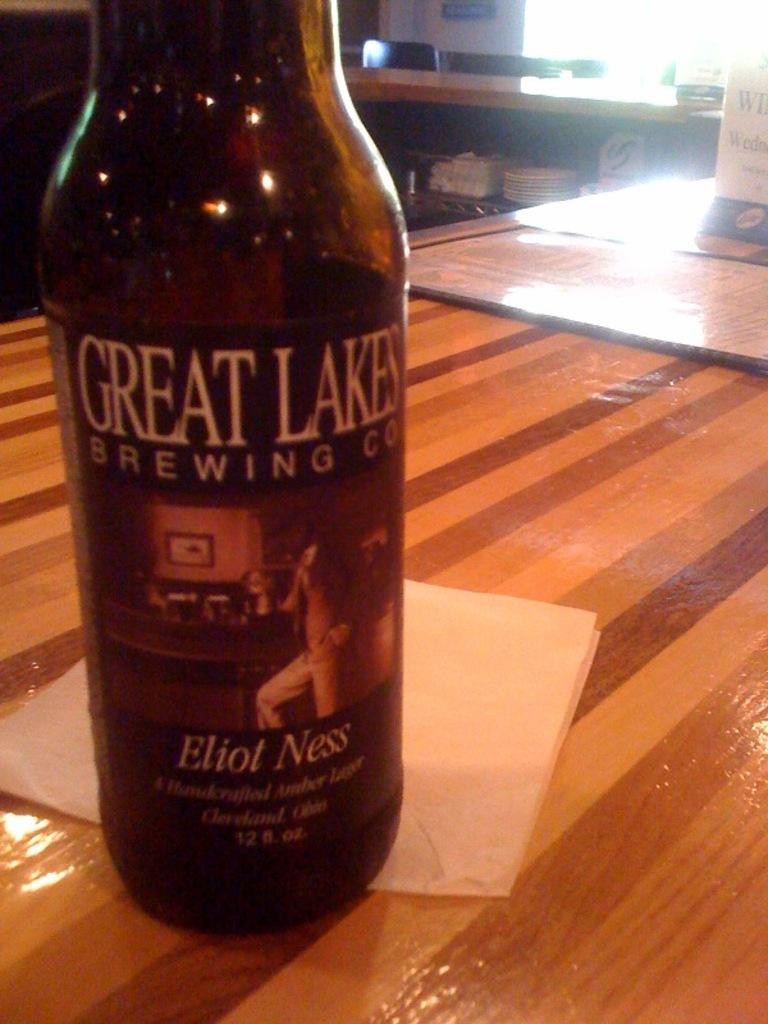Provide a one-sentence caption for the provided image. A bottle says "GREAT LAKES BREWING CO" on the front. 